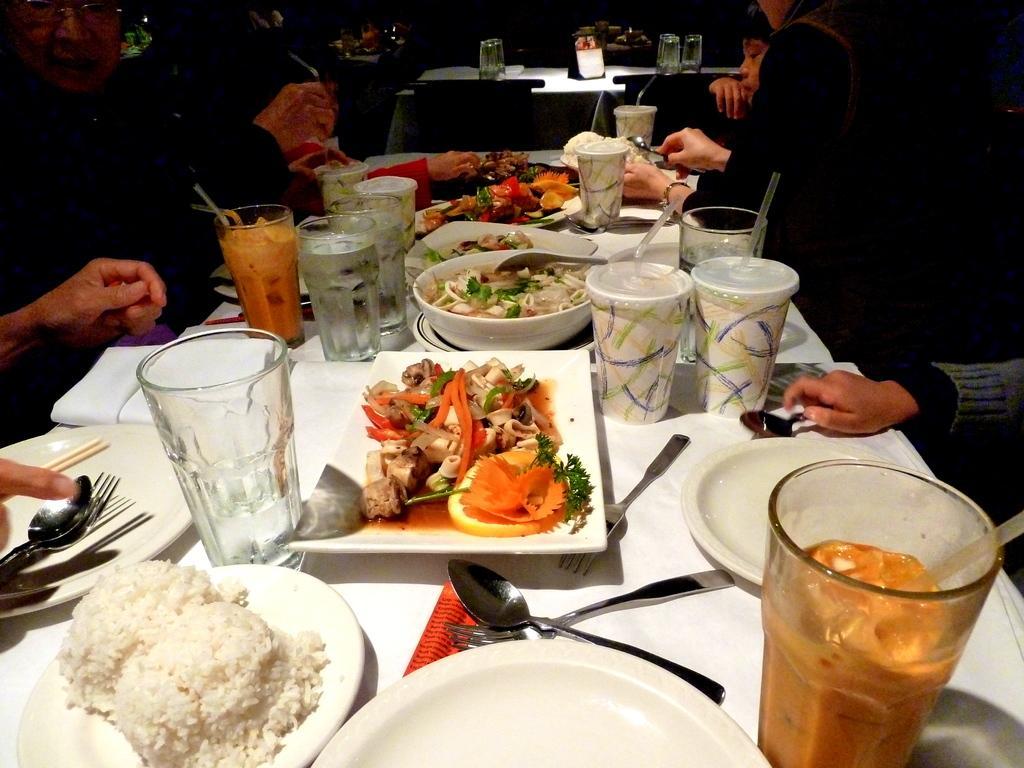In one or two sentences, can you explain what this image depicts? In this image I can see the white color table. On the table I can see many plates, bottles, cups, spoons and forks. I can also see some bowls with food. And there are few people sitting in-front of the table and wearing the different color dresses. 